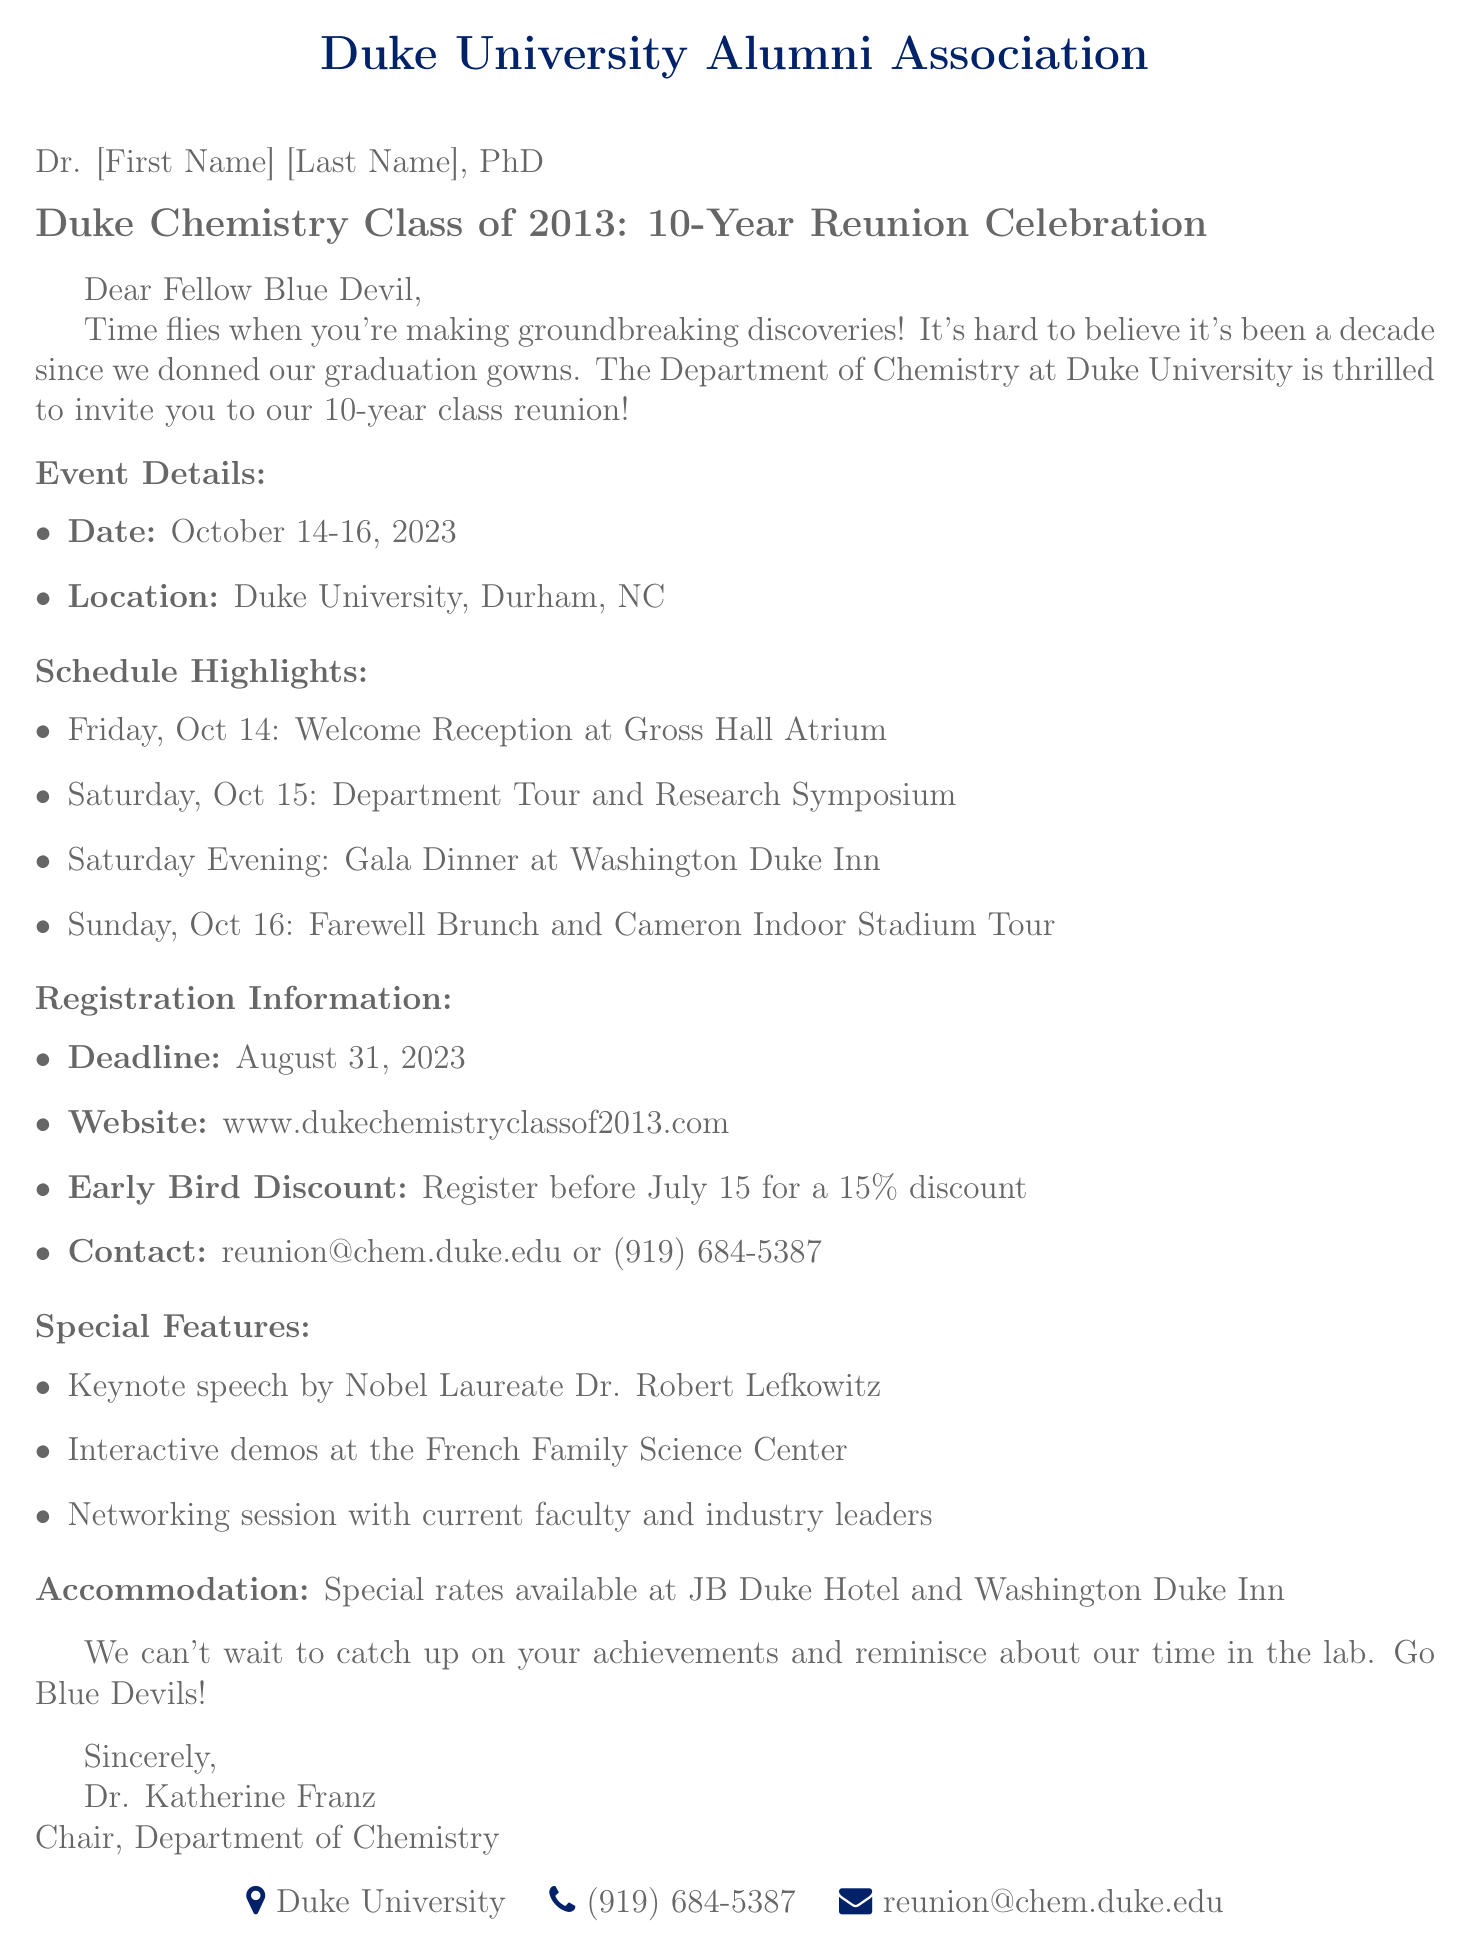What are the dates of the reunion? The document lists the event details under "Event Details," specifying the date range for the reunion.
Answer: October 14-16, 2023 Where is the reunion taking place? The event details section provides the location of the reunion event.
Answer: Duke University, Durham, NC What is the registration deadline? The registration information section mentions a deadline for registration.
Answer: August 31, 2023 What discount is available for early registration? The registration information includes a detail about early registration discounts.
Answer: 15% discount Who is giving the keynote speech? The special features section includes information about a specific speaker at the event.
Answer: Dr. Robert Lefkowitz What event is scheduled for Saturday evening? The schedule highlights list events taking place on Saturday evening.
Answer: Gala Dinner at Washington Duke Inn What type of accommodations are mentioned? The document discusses special rates which provide information on where attendees can stay.
Answer: Special rates available at JB Duke Hotel and Washington Duke Inn What is the main purpose of this mail? The introduction outlines the primary reason and excitement behind the mailing.
Answer: Invitation to a reunion Which email can be used for contact regarding the event? The registration information provides a contact method for inquiries regarding the reunion.
Answer: reunion@chem.duke.edu What is the title of the document? The document's subject line specifies the title relating to the reunion event.
Answer: Duke Chemistry Class of 2013: 10-Year Reunion Celebration 